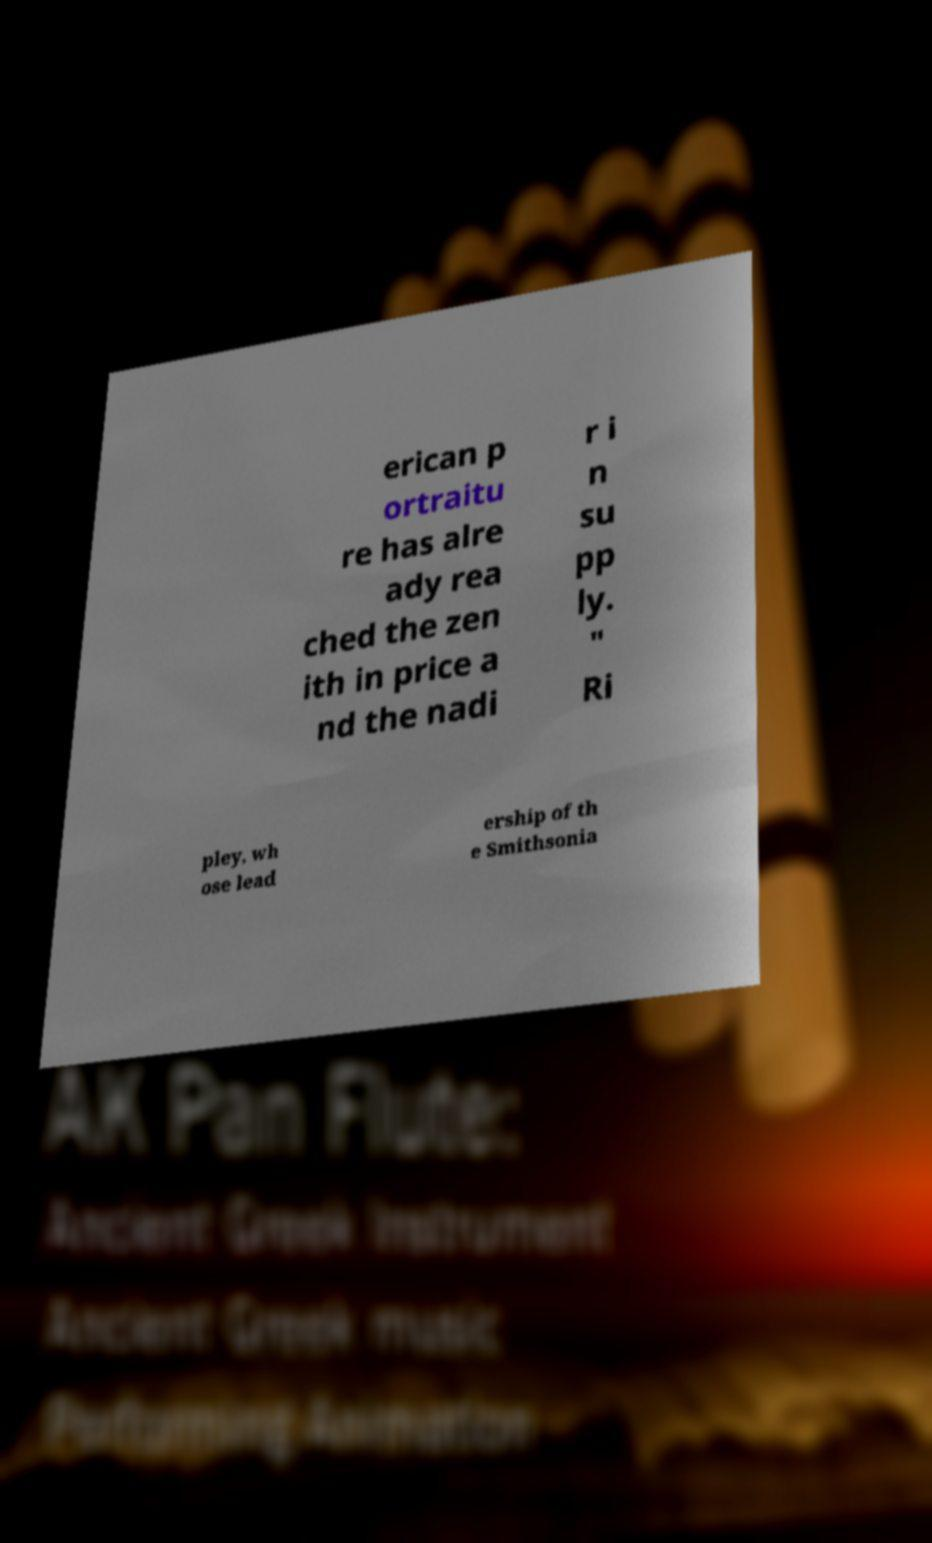For documentation purposes, I need the text within this image transcribed. Could you provide that? erican p ortraitu re has alre ady rea ched the zen ith in price a nd the nadi r i n su pp ly. " Ri pley, wh ose lead ership of th e Smithsonia 